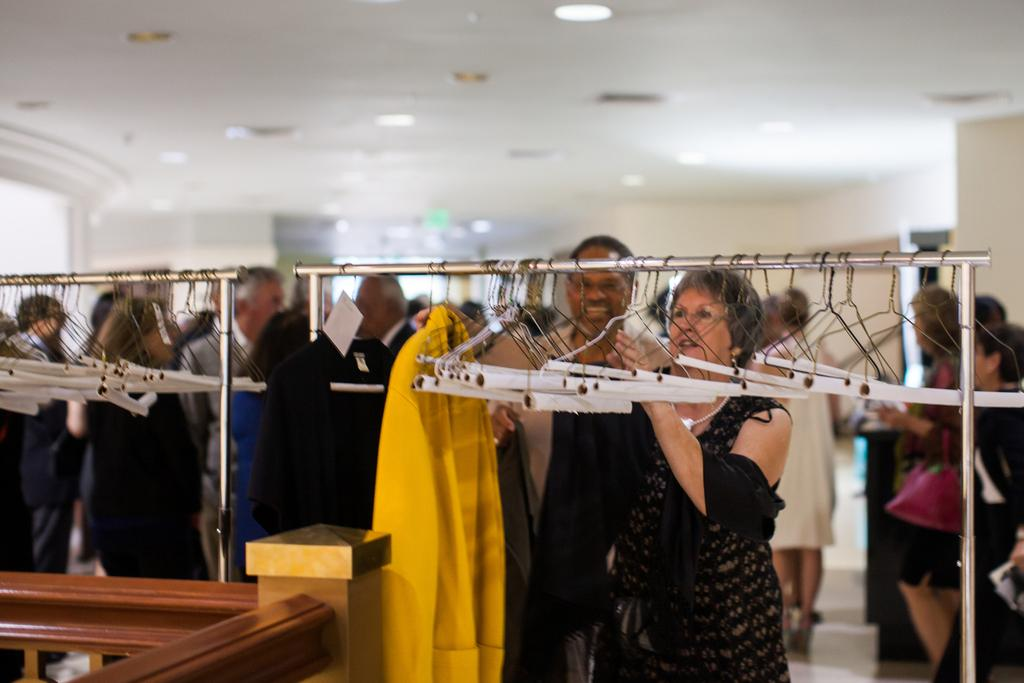What can be seen on the stand in the image? There are hangers on a stand in the image. Who or what is located at the bottom of the image? There are people at the bottom of the image. Can you describe the background of the image? There are people and a wall in the background of the image, along with lights. What is the opinion of the kitten in the image? There is no kitten present in the image, so it is not possible to determine its opinion. 